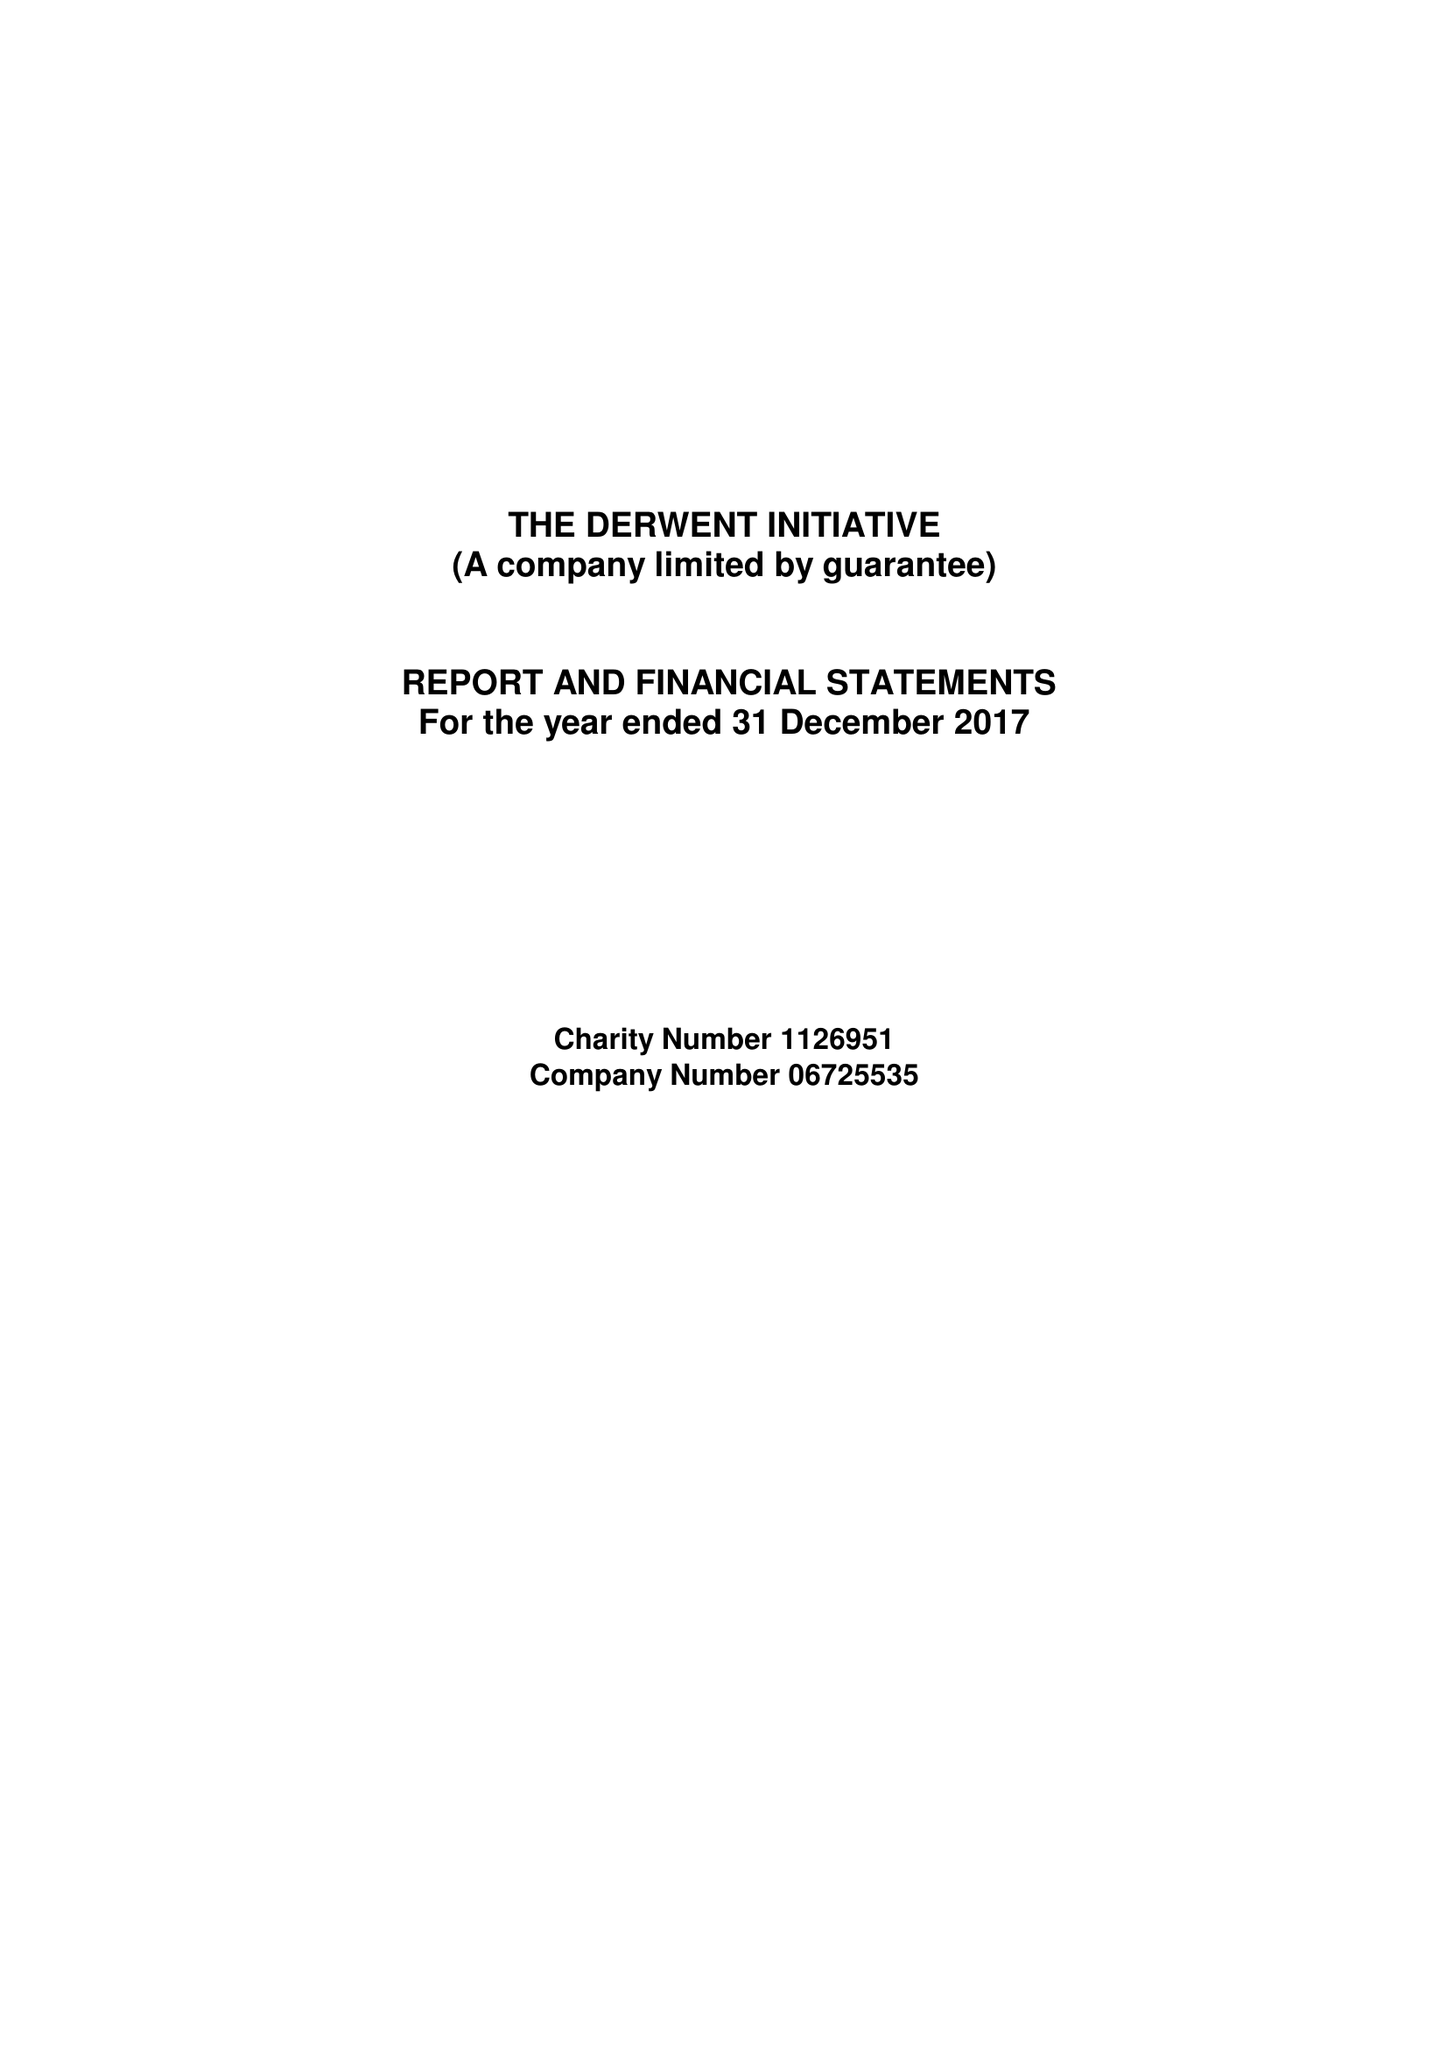What is the value for the address__postcode?
Answer the question using a single word or phrase. NE1 5HX 